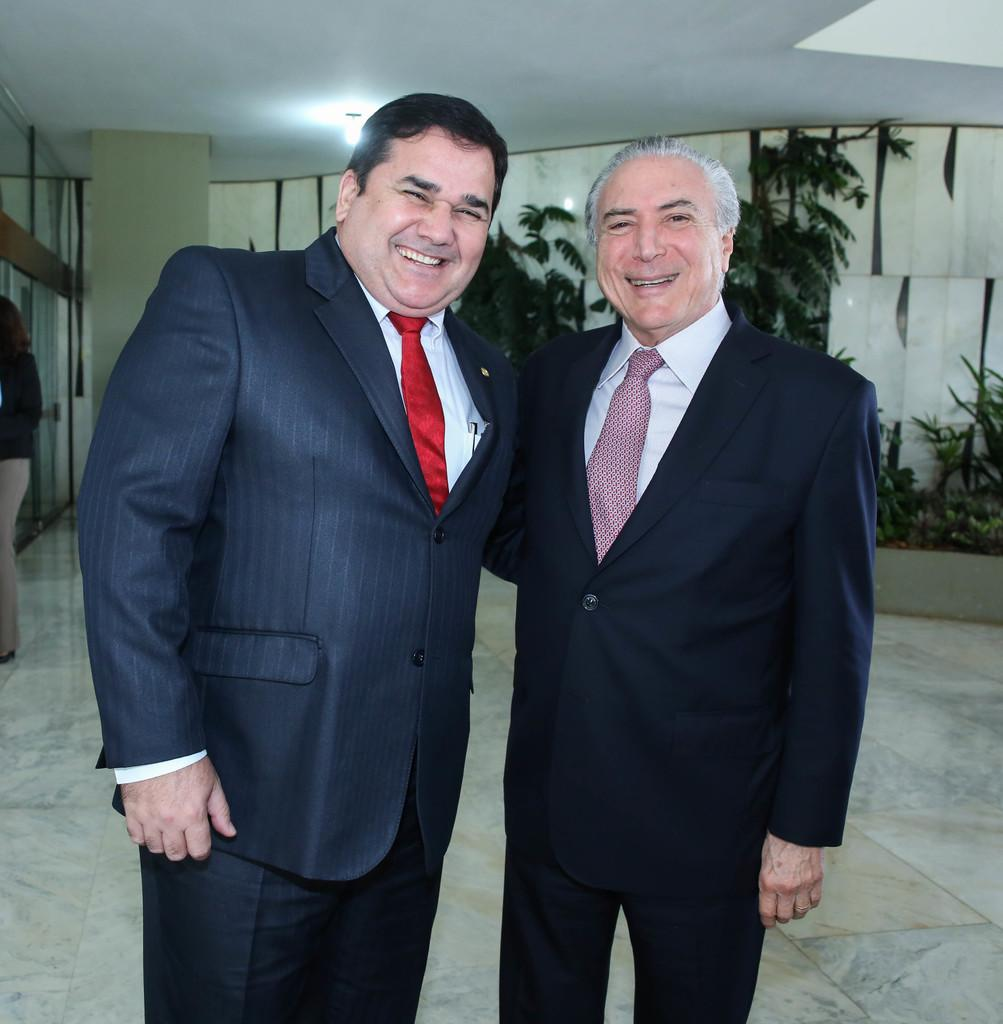How many people are in the image? There are two men in the image. What are the men doing in the image? The men are standing and smiling. What can be seen in the background of the image? There is a wall, plants, and a light source in the background of the image. Can you see a donkey rubbing against the wall in the image? No, there is no donkey present in the image. 